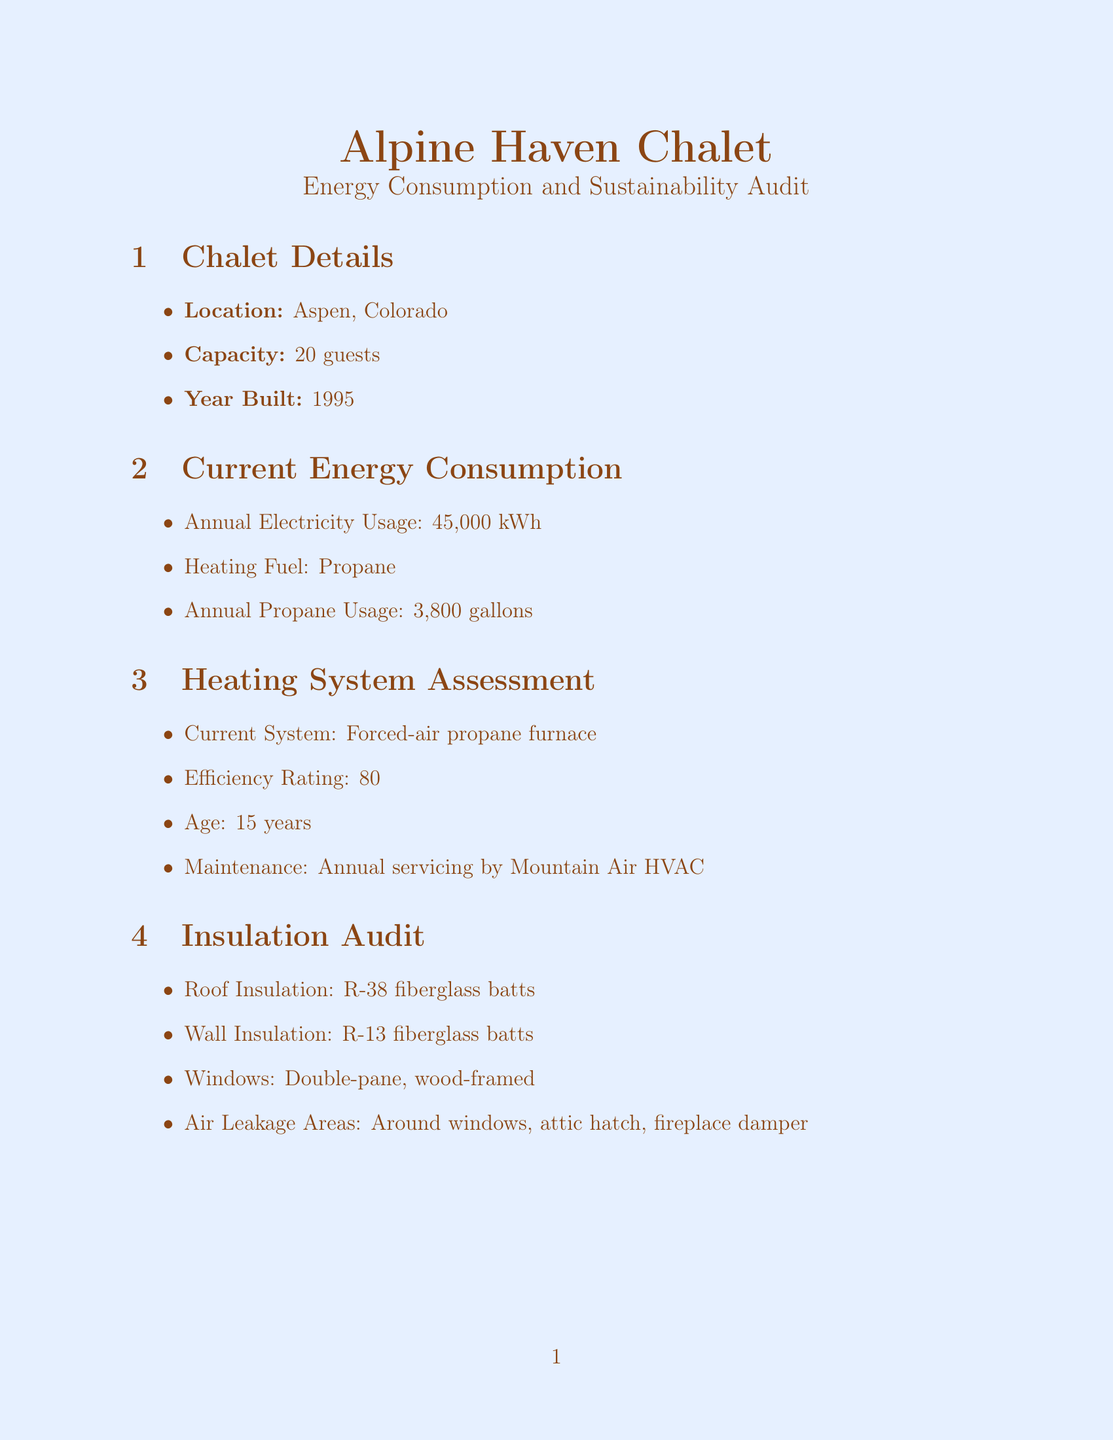What is the capacity of the Alpine Haven Chalet? The capacity is directly stated in the chalet details section, which mentions it can accommodate 20 guests.
Answer: 20 guests What is the annual propane usage? The annual propane usage is specified in the current energy consumption, which states it is 3,800 gallons.
Answer: 3,800 gallons What is the efficiency rating of the heating system? The efficiency rating is listed in the heating system assessment, which shows it is 80% AFUE.
Answer: 80% AFUE What are two potential improvements for eco-friendly practices? The potential improvements are mentioned in the eco-friendly practices section, where composting and rainwater harvesting are included.
Answer: Composting system, rainwater harvesting What is the estimated annual solar panel production? The estimated annual production of solar panels is found in the renewable energy potential section, stating it produces 18,000 kWh.
Answer: 18,000 kWh What is the feasibility of the geothermal heat pump? The feasibility is noted in the geothermal heat pump subsection, which indicates a high feasibility.
Answer: High Which utility provider offers sustainability incentives? The utility provider is mentioned in the local sustainability programs section and is identified as Holy Cross Energy.
Answer: Holy Cross Energy What type of windows does the chalet have? The type of windows is mentioned in the insulation audit, which states they are double-pane, wood-framed.
Answer: Double-pane, wood-framed How many similar properties are compared in the benchmark comparison? The benchmark comparison section includes two similar properties to compare against the Alpine Haven Chalet.
Answer: Two 